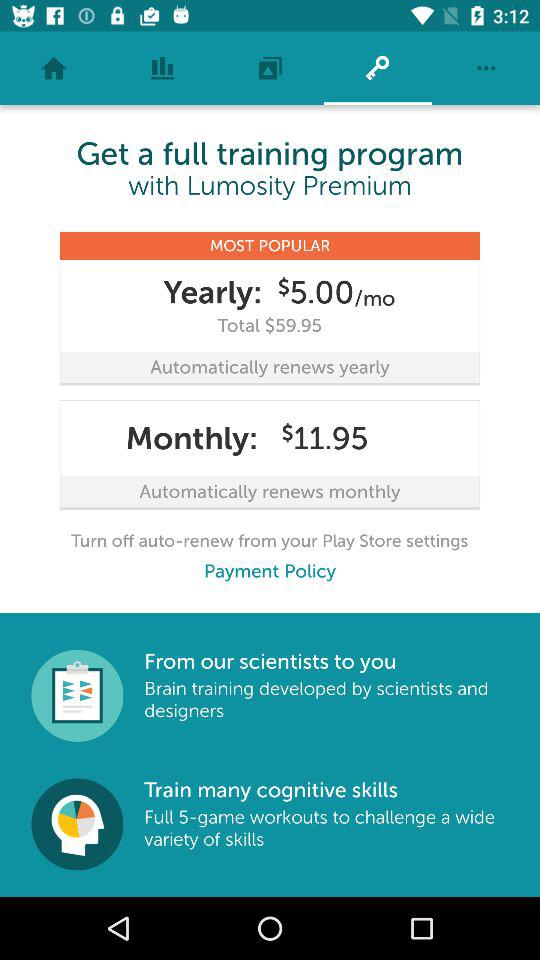What is the yearly charge for a full training program? The yearly charge for a full training program is $59.95. 